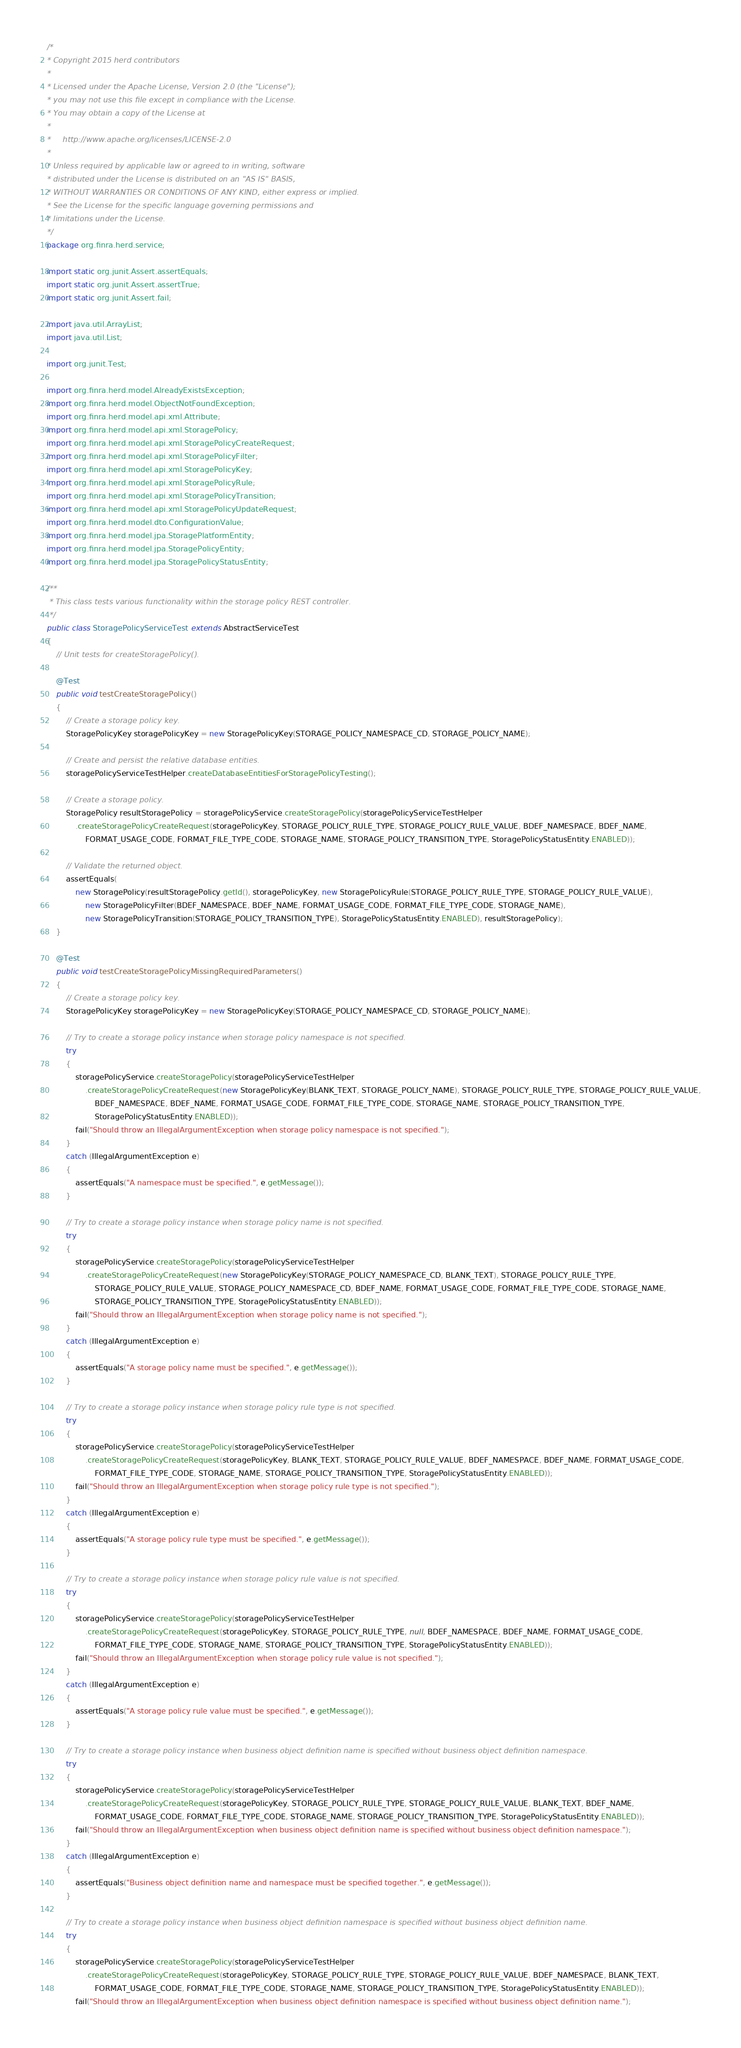<code> <loc_0><loc_0><loc_500><loc_500><_Java_>/*
* Copyright 2015 herd contributors
*
* Licensed under the Apache License, Version 2.0 (the "License");
* you may not use this file except in compliance with the License.
* You may obtain a copy of the License at
*
*     http://www.apache.org/licenses/LICENSE-2.0
*
* Unless required by applicable law or agreed to in writing, software
* distributed under the License is distributed on an "AS IS" BASIS,
* WITHOUT WARRANTIES OR CONDITIONS OF ANY KIND, either express or implied.
* See the License for the specific language governing permissions and
* limitations under the License.
*/
package org.finra.herd.service;

import static org.junit.Assert.assertEquals;
import static org.junit.Assert.assertTrue;
import static org.junit.Assert.fail;

import java.util.ArrayList;
import java.util.List;

import org.junit.Test;

import org.finra.herd.model.AlreadyExistsException;
import org.finra.herd.model.ObjectNotFoundException;
import org.finra.herd.model.api.xml.Attribute;
import org.finra.herd.model.api.xml.StoragePolicy;
import org.finra.herd.model.api.xml.StoragePolicyCreateRequest;
import org.finra.herd.model.api.xml.StoragePolicyFilter;
import org.finra.herd.model.api.xml.StoragePolicyKey;
import org.finra.herd.model.api.xml.StoragePolicyRule;
import org.finra.herd.model.api.xml.StoragePolicyTransition;
import org.finra.herd.model.api.xml.StoragePolicyUpdateRequest;
import org.finra.herd.model.dto.ConfigurationValue;
import org.finra.herd.model.jpa.StoragePlatformEntity;
import org.finra.herd.model.jpa.StoragePolicyEntity;
import org.finra.herd.model.jpa.StoragePolicyStatusEntity;

/**
 * This class tests various functionality within the storage policy REST controller.
 */
public class StoragePolicyServiceTest extends AbstractServiceTest
{
    // Unit tests for createStoragePolicy().

    @Test
    public void testCreateStoragePolicy()
    {
        // Create a storage policy key.
        StoragePolicyKey storagePolicyKey = new StoragePolicyKey(STORAGE_POLICY_NAMESPACE_CD, STORAGE_POLICY_NAME);

        // Create and persist the relative database entities.
        storagePolicyServiceTestHelper.createDatabaseEntitiesForStoragePolicyTesting();

        // Create a storage policy.
        StoragePolicy resultStoragePolicy = storagePolicyService.createStoragePolicy(storagePolicyServiceTestHelper
            .createStoragePolicyCreateRequest(storagePolicyKey, STORAGE_POLICY_RULE_TYPE, STORAGE_POLICY_RULE_VALUE, BDEF_NAMESPACE, BDEF_NAME,
                FORMAT_USAGE_CODE, FORMAT_FILE_TYPE_CODE, STORAGE_NAME, STORAGE_POLICY_TRANSITION_TYPE, StoragePolicyStatusEntity.ENABLED));

        // Validate the returned object.
        assertEquals(
            new StoragePolicy(resultStoragePolicy.getId(), storagePolicyKey, new StoragePolicyRule(STORAGE_POLICY_RULE_TYPE, STORAGE_POLICY_RULE_VALUE),
                new StoragePolicyFilter(BDEF_NAMESPACE, BDEF_NAME, FORMAT_USAGE_CODE, FORMAT_FILE_TYPE_CODE, STORAGE_NAME),
                new StoragePolicyTransition(STORAGE_POLICY_TRANSITION_TYPE), StoragePolicyStatusEntity.ENABLED), resultStoragePolicy);
    }

    @Test
    public void testCreateStoragePolicyMissingRequiredParameters()
    {
        // Create a storage policy key.
        StoragePolicyKey storagePolicyKey = new StoragePolicyKey(STORAGE_POLICY_NAMESPACE_CD, STORAGE_POLICY_NAME);

        // Try to create a storage policy instance when storage policy namespace is not specified.
        try
        {
            storagePolicyService.createStoragePolicy(storagePolicyServiceTestHelper
                .createStoragePolicyCreateRequest(new StoragePolicyKey(BLANK_TEXT, STORAGE_POLICY_NAME), STORAGE_POLICY_RULE_TYPE, STORAGE_POLICY_RULE_VALUE,
                    BDEF_NAMESPACE, BDEF_NAME, FORMAT_USAGE_CODE, FORMAT_FILE_TYPE_CODE, STORAGE_NAME, STORAGE_POLICY_TRANSITION_TYPE,
                    StoragePolicyStatusEntity.ENABLED));
            fail("Should throw an IllegalArgumentException when storage policy namespace is not specified.");
        }
        catch (IllegalArgumentException e)
        {
            assertEquals("A namespace must be specified.", e.getMessage());
        }

        // Try to create a storage policy instance when storage policy name is not specified.
        try
        {
            storagePolicyService.createStoragePolicy(storagePolicyServiceTestHelper
                .createStoragePolicyCreateRequest(new StoragePolicyKey(STORAGE_POLICY_NAMESPACE_CD, BLANK_TEXT), STORAGE_POLICY_RULE_TYPE,
                    STORAGE_POLICY_RULE_VALUE, STORAGE_POLICY_NAMESPACE_CD, BDEF_NAME, FORMAT_USAGE_CODE, FORMAT_FILE_TYPE_CODE, STORAGE_NAME,
                    STORAGE_POLICY_TRANSITION_TYPE, StoragePolicyStatusEntity.ENABLED));
            fail("Should throw an IllegalArgumentException when storage policy name is not specified.");
        }
        catch (IllegalArgumentException e)
        {
            assertEquals("A storage policy name must be specified.", e.getMessage());
        }

        // Try to create a storage policy instance when storage policy rule type is not specified.
        try
        {
            storagePolicyService.createStoragePolicy(storagePolicyServiceTestHelper
                .createStoragePolicyCreateRequest(storagePolicyKey, BLANK_TEXT, STORAGE_POLICY_RULE_VALUE, BDEF_NAMESPACE, BDEF_NAME, FORMAT_USAGE_CODE,
                    FORMAT_FILE_TYPE_CODE, STORAGE_NAME, STORAGE_POLICY_TRANSITION_TYPE, StoragePolicyStatusEntity.ENABLED));
            fail("Should throw an IllegalArgumentException when storage policy rule type is not specified.");
        }
        catch (IllegalArgumentException e)
        {
            assertEquals("A storage policy rule type must be specified.", e.getMessage());
        }

        // Try to create a storage policy instance when storage policy rule value is not specified.
        try
        {
            storagePolicyService.createStoragePolicy(storagePolicyServiceTestHelper
                .createStoragePolicyCreateRequest(storagePolicyKey, STORAGE_POLICY_RULE_TYPE, null, BDEF_NAMESPACE, BDEF_NAME, FORMAT_USAGE_CODE,
                    FORMAT_FILE_TYPE_CODE, STORAGE_NAME, STORAGE_POLICY_TRANSITION_TYPE, StoragePolicyStatusEntity.ENABLED));
            fail("Should throw an IllegalArgumentException when storage policy rule value is not specified.");
        }
        catch (IllegalArgumentException e)
        {
            assertEquals("A storage policy rule value must be specified.", e.getMessage());
        }

        // Try to create a storage policy instance when business object definition name is specified without business object definition namespace.
        try
        {
            storagePolicyService.createStoragePolicy(storagePolicyServiceTestHelper
                .createStoragePolicyCreateRequest(storagePolicyKey, STORAGE_POLICY_RULE_TYPE, STORAGE_POLICY_RULE_VALUE, BLANK_TEXT, BDEF_NAME,
                    FORMAT_USAGE_CODE, FORMAT_FILE_TYPE_CODE, STORAGE_NAME, STORAGE_POLICY_TRANSITION_TYPE, StoragePolicyStatusEntity.ENABLED));
            fail("Should throw an IllegalArgumentException when business object definition name is specified without business object definition namespace.");
        }
        catch (IllegalArgumentException e)
        {
            assertEquals("Business object definition name and namespace must be specified together.", e.getMessage());
        }

        // Try to create a storage policy instance when business object definition namespace is specified without business object definition name.
        try
        {
            storagePolicyService.createStoragePolicy(storagePolicyServiceTestHelper
                .createStoragePolicyCreateRequest(storagePolicyKey, STORAGE_POLICY_RULE_TYPE, STORAGE_POLICY_RULE_VALUE, BDEF_NAMESPACE, BLANK_TEXT,
                    FORMAT_USAGE_CODE, FORMAT_FILE_TYPE_CODE, STORAGE_NAME, STORAGE_POLICY_TRANSITION_TYPE, StoragePolicyStatusEntity.ENABLED));
            fail("Should throw an IllegalArgumentException when business object definition namespace is specified without business object definition name.");</code> 